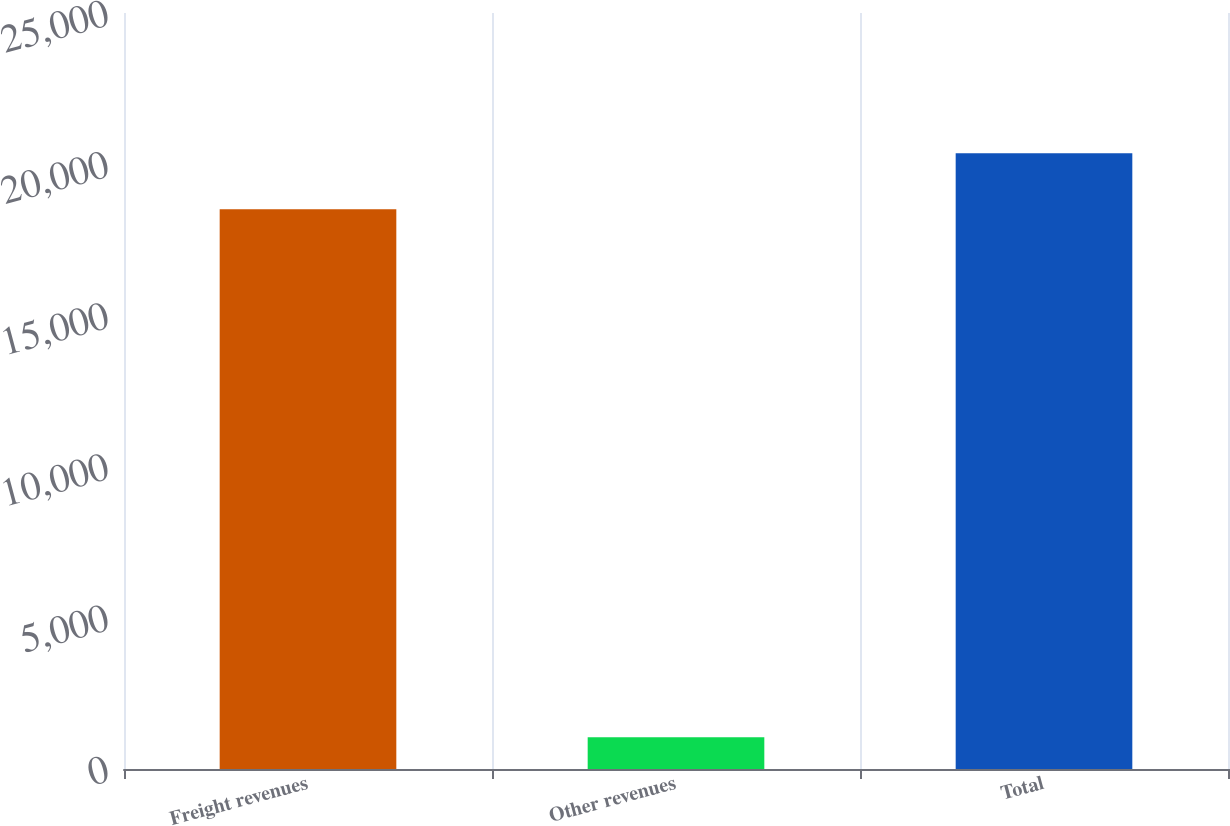Convert chart. <chart><loc_0><loc_0><loc_500><loc_500><bar_chart><fcel>Freight revenues<fcel>Other revenues<fcel>Total<nl><fcel>18508<fcel>1049<fcel>20358.8<nl></chart> 